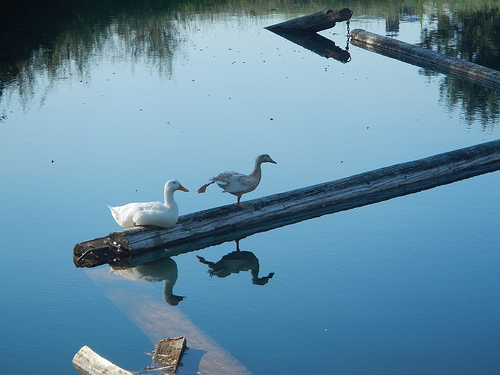<image>
Can you confirm if the duck is in front of the duck? Yes. The duck is positioned in front of the duck, appearing closer to the camera viewpoint. 